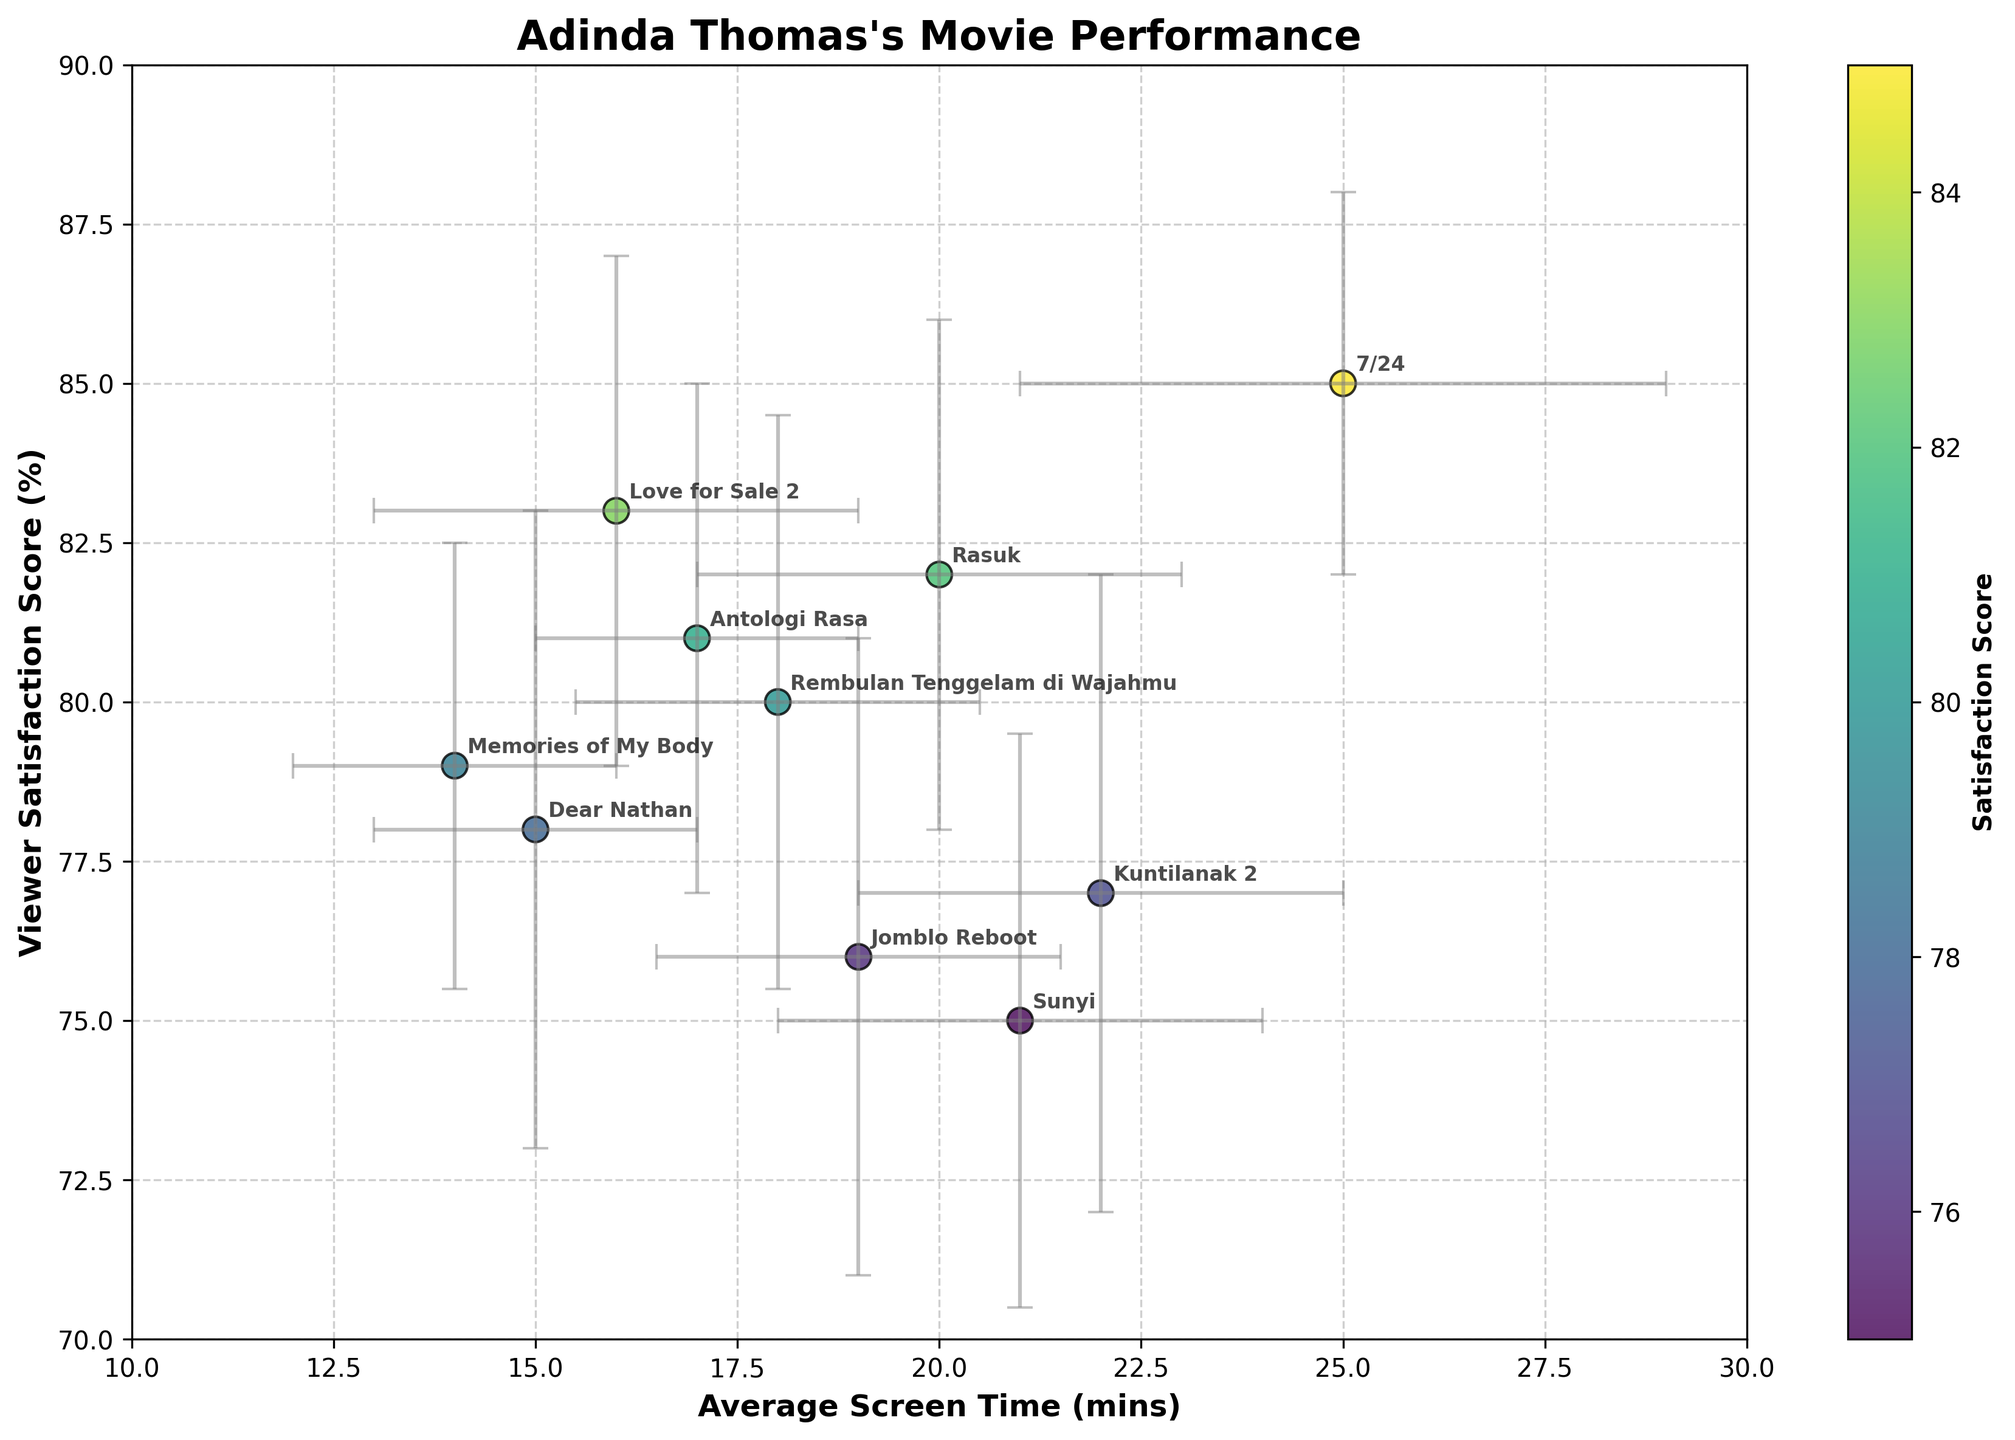How many movies are data points in the figure? By counting the number of distinct points labeled with movie titles in the dot plot, we can determine there are 10.
Answer: 10 What is the title of the movie with the highest average screen time of Adinda Thomas? The movie with the highest average screen time can be identified by finding the point on the x-axis farthest to the right, labeled "7/24".
Answer: "7/24" Which movie has the lowest viewer satisfaction score and what is that score? The movie with the lowest viewer satisfaction score is represented by the point with the lowest value on the y-axis, labeled "Sunyi", scoring 75%.
Answer: "Sunyi", 75% What's the difference in average screen time between "Dear Nathan" and "7/24"? The average screen time for "Dear Nathan" is 15 minutes and for "7/24" is 25 minutes. The difference is 25 - 15 = 10 minutes.
Answer: 10 minutes Which movie has the smallest error bar for the satisfaction score? Observing the lengths of the vertical error bars, "7/24" has the smallest, indicating it has the smallest standard deviation for satisfaction score.
Answer: "7/24" How many movies have an average satisfaction score above 80%? By identifying points above the 80% line on the y-axis, we find that five movies meet this criterion: "Rasuk", "7/24", "Antologi Rasa", "Love for Sale 2", and "Dear Nathan".
Answer: 5 Which movies have an average screen time within the range of 15 to 18 minutes? By looking at the range between 15 and 18 minutes on the x-axis, the movies are "Dear Nathan", "Antologi Rasa", "Love for Sale 2", and "Memories of My Body".
Answer: "Dear Nathan", "Antologi Rasa", "Love for Sale 2", "Memories of My Body" Which movie has the highest standard deviation in screen time, and what is the value? Observing the lengths of the horizontal error bars, "7/24" has the longest bar indicating the highest standard deviation of 4 minutes.
Answer: "7/24", 4 minutes Do most movies listed have an average satisfaction score greater than 75% and lower than 85%? Counting how many points fall within this range on the y-axis: "Dear Nathan", "Rasuk", "Rembulan Tenggelam di Wajahmu", "Antologi Rasa", "Memories of My Body", "Love for Sale 2", and "Jomblo Reboot" (7 out of 10), confirms it.
Answer: Yes, most do What is the average satisfaction score of the movies "Kuntilanak 2" and "Sunyi"? The satisfaction scores are 77% and 75% respectively. The average is (77 + 75) / 2 = 76%.
Answer: 76% 